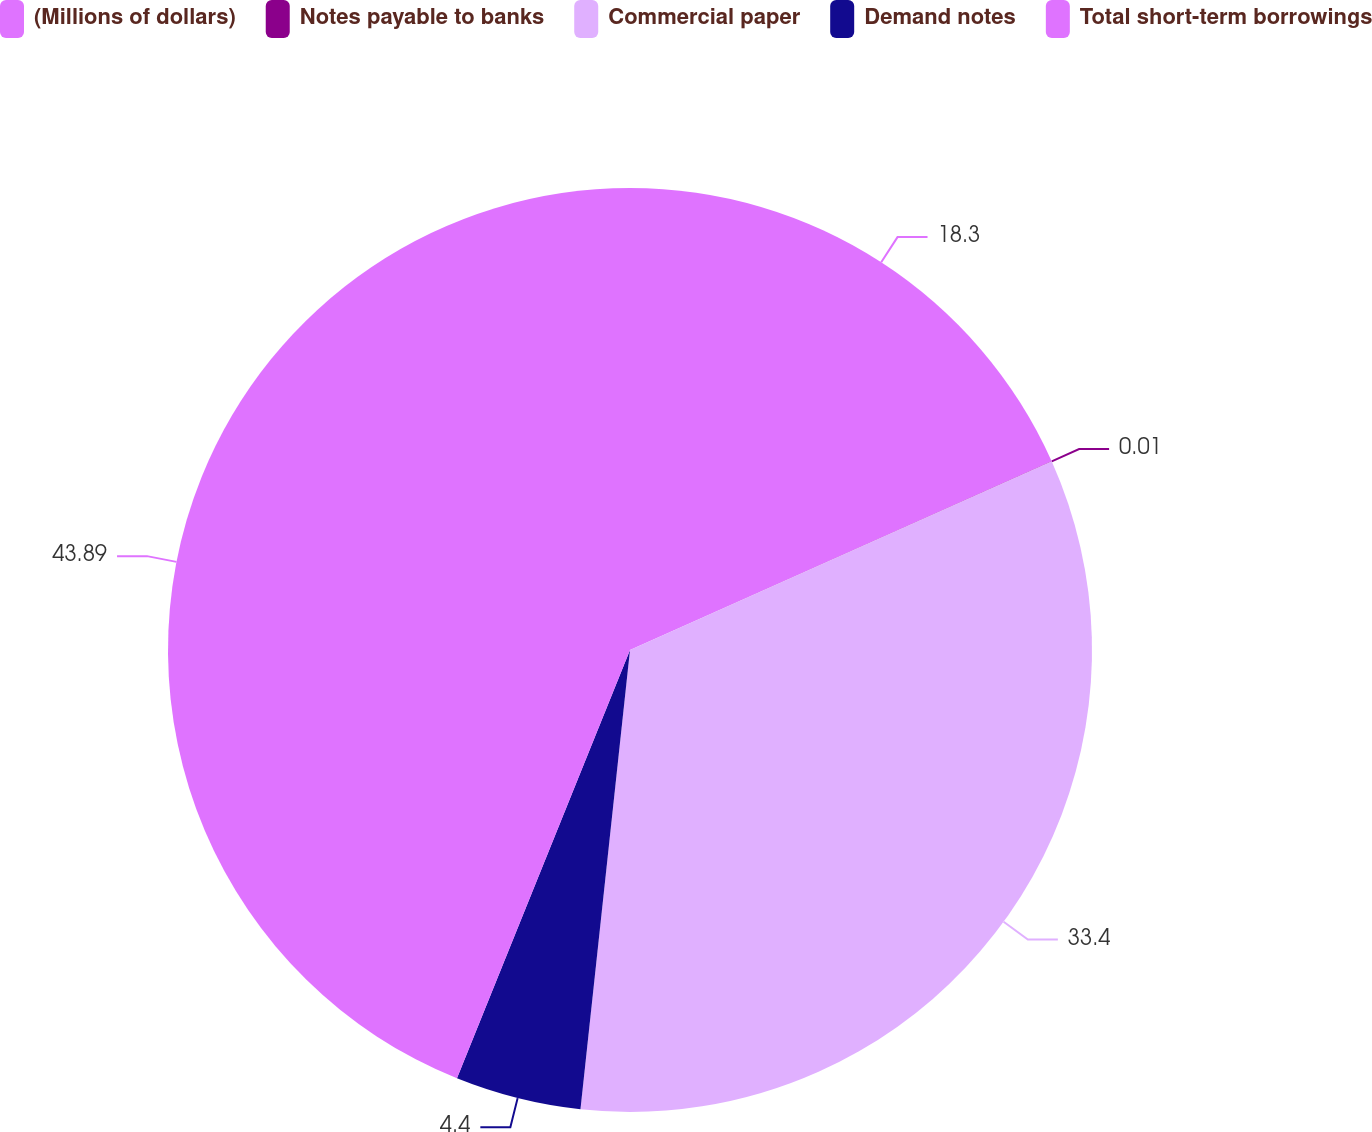<chart> <loc_0><loc_0><loc_500><loc_500><pie_chart><fcel>(Millions of dollars)<fcel>Notes payable to banks<fcel>Commercial paper<fcel>Demand notes<fcel>Total short-term borrowings<nl><fcel>18.3%<fcel>0.01%<fcel>33.4%<fcel>4.4%<fcel>43.89%<nl></chart> 